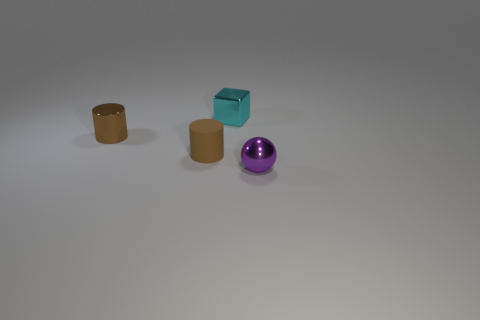Subtract all blocks. How many objects are left? 3 Add 1 purple metal spheres. How many objects exist? 5 Subtract 2 brown cylinders. How many objects are left? 2 Subtract 1 cubes. How many cubes are left? 0 Subtract all purple cylinders. Subtract all brown blocks. How many cylinders are left? 2 Subtract all yellow balls. How many gray cylinders are left? 0 Subtract all small brown rubber cylinders. Subtract all small spheres. How many objects are left? 2 Add 3 small shiny things. How many small shiny things are left? 6 Add 1 large brown matte spheres. How many large brown matte spheres exist? 1 